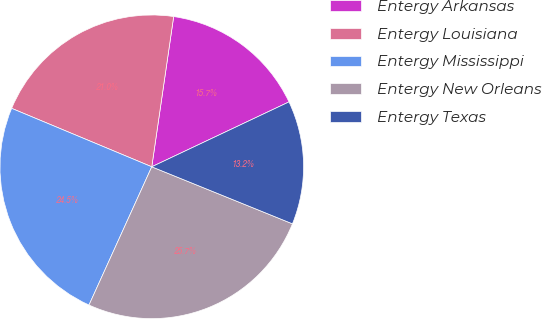Convert chart. <chart><loc_0><loc_0><loc_500><loc_500><pie_chart><fcel>Entergy Arkansas<fcel>Entergy Louisiana<fcel>Entergy Mississippi<fcel>Entergy New Orleans<fcel>Entergy Texas<nl><fcel>15.67%<fcel>21.02%<fcel>24.51%<fcel>25.66%<fcel>13.16%<nl></chart> 